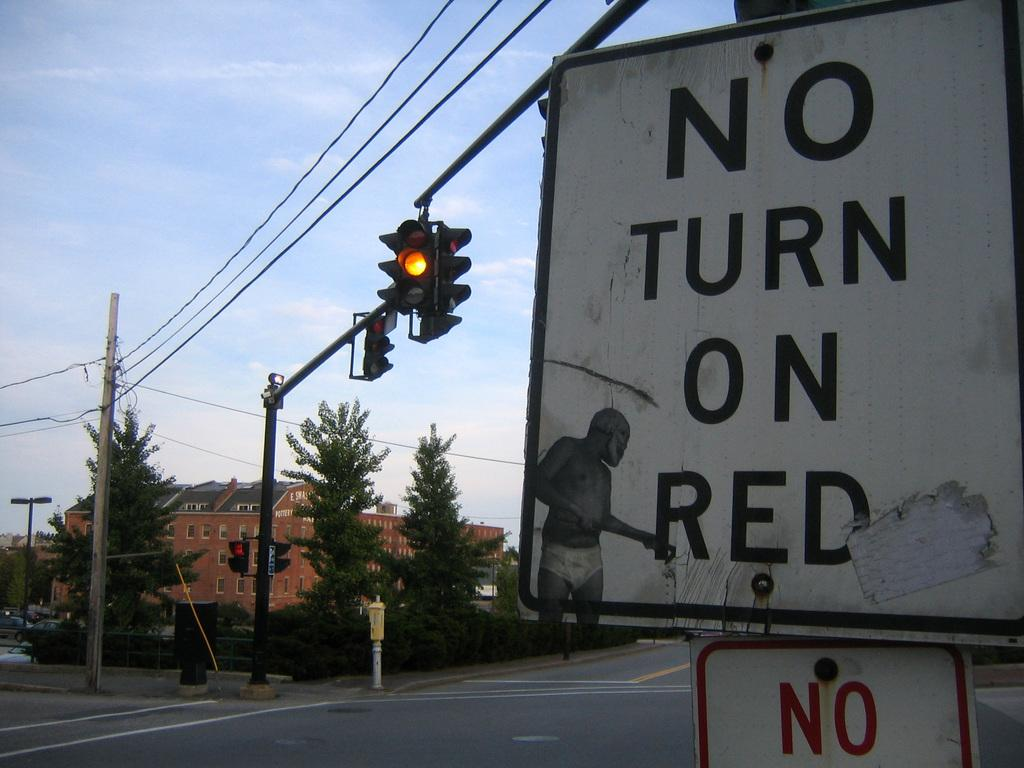<image>
Create a compact narrative representing the image presented. A yellow light that has a no turn on red sign  to the right of it. 